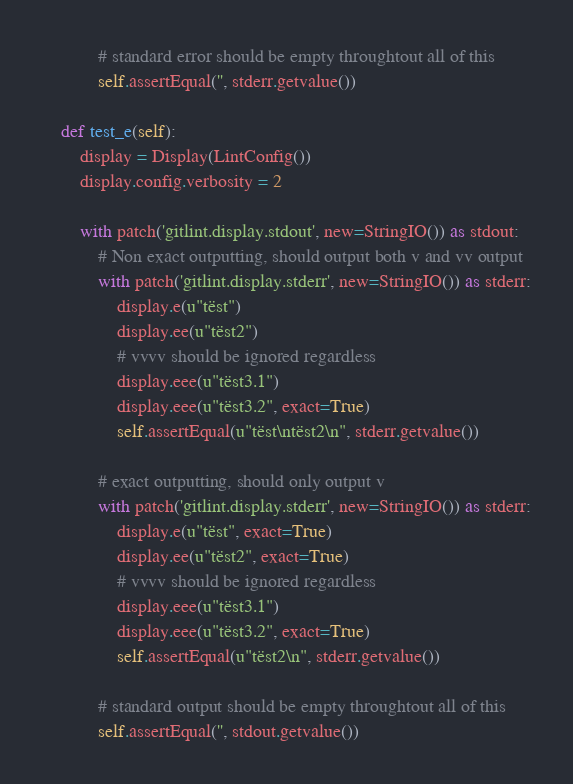<code> <loc_0><loc_0><loc_500><loc_500><_Python_>            # standard error should be empty throughtout all of this
            self.assertEqual('', stderr.getvalue())

    def test_e(self):
        display = Display(LintConfig())
        display.config.verbosity = 2

        with patch('gitlint.display.stdout', new=StringIO()) as stdout:
            # Non exact outputting, should output both v and vv output
            with patch('gitlint.display.stderr', new=StringIO()) as stderr:
                display.e(u"tëst")
                display.ee(u"tëst2")
                # vvvv should be ignored regardless
                display.eee(u"tëst3.1")
                display.eee(u"tëst3.2", exact=True)
                self.assertEqual(u"tëst\ntëst2\n", stderr.getvalue())

            # exact outputting, should only output v
            with patch('gitlint.display.stderr', new=StringIO()) as stderr:
                display.e(u"tëst", exact=True)
                display.ee(u"tëst2", exact=True)
                # vvvv should be ignored regardless
                display.eee(u"tëst3.1")
                display.eee(u"tëst3.2", exact=True)
                self.assertEqual(u"tëst2\n", stderr.getvalue())

            # standard output should be empty throughtout all of this
            self.assertEqual('', stdout.getvalue())
</code> 